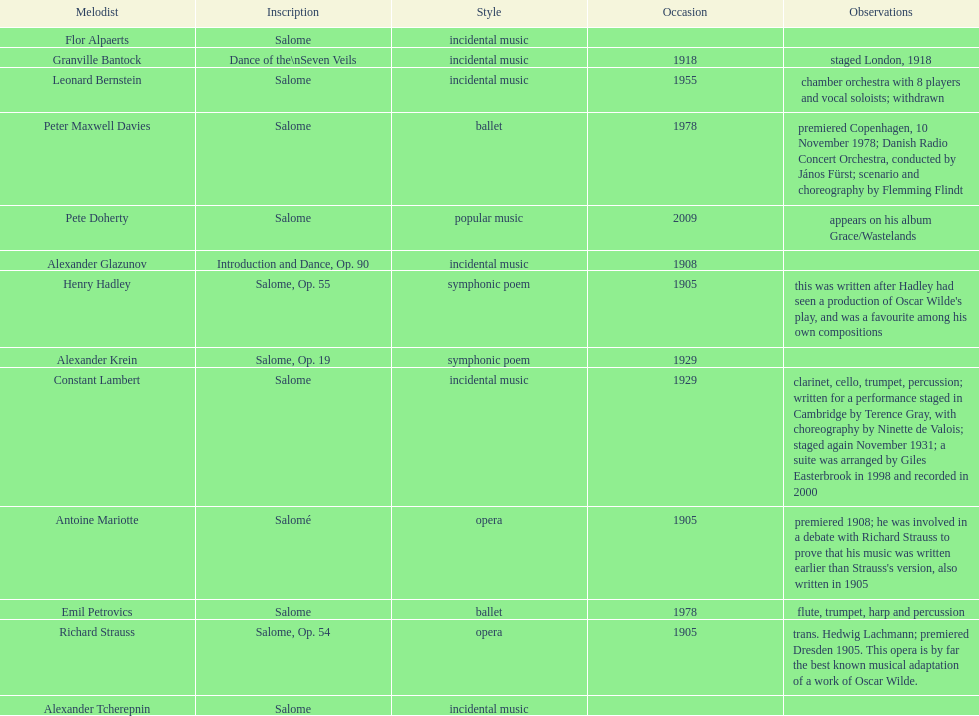Who is on top of the list? Flor Alpaerts. 